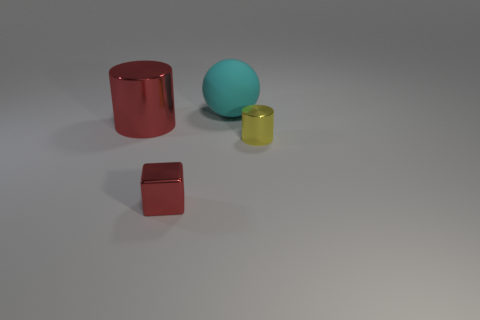What number of objects are large objects that are left of the matte object or tiny matte blocks?
Provide a short and direct response. 1. What number of other things are there of the same size as the rubber object?
Ensure brevity in your answer.  1. What is the material of the tiny thing that is on the right side of the small thing that is to the left of the big matte thing that is to the right of the small metallic cube?
Provide a succinct answer. Metal. How many cylinders are large cyan objects or small yellow shiny things?
Your response must be concise. 1. Are there any other things that are the same shape as the small red metal thing?
Give a very brief answer. No. Is the number of cyan matte objects that are left of the red block greater than the number of red objects behind the cyan ball?
Make the answer very short. No. How many red metallic blocks are to the right of the large object on the right side of the big red cylinder?
Keep it short and to the point. 0. What number of things are either big matte things or small yellow metallic objects?
Give a very brief answer. 2. Is the shape of the small red object the same as the small yellow metallic object?
Make the answer very short. No. What is the big cyan thing made of?
Your answer should be very brief. Rubber. 